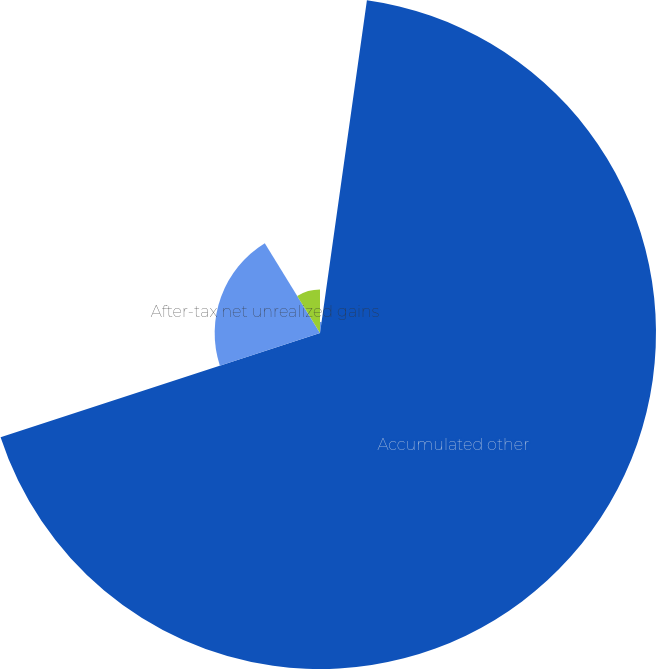<chart> <loc_0><loc_0><loc_500><loc_500><pie_chart><fcel>(Thousands of Dollars)<fcel>Accumulated other<fcel>After-tax net unrealized gains<fcel>After-tax net realized losses<nl><fcel>2.23%<fcel>67.75%<fcel>21.24%<fcel>8.78%<nl></chart> 